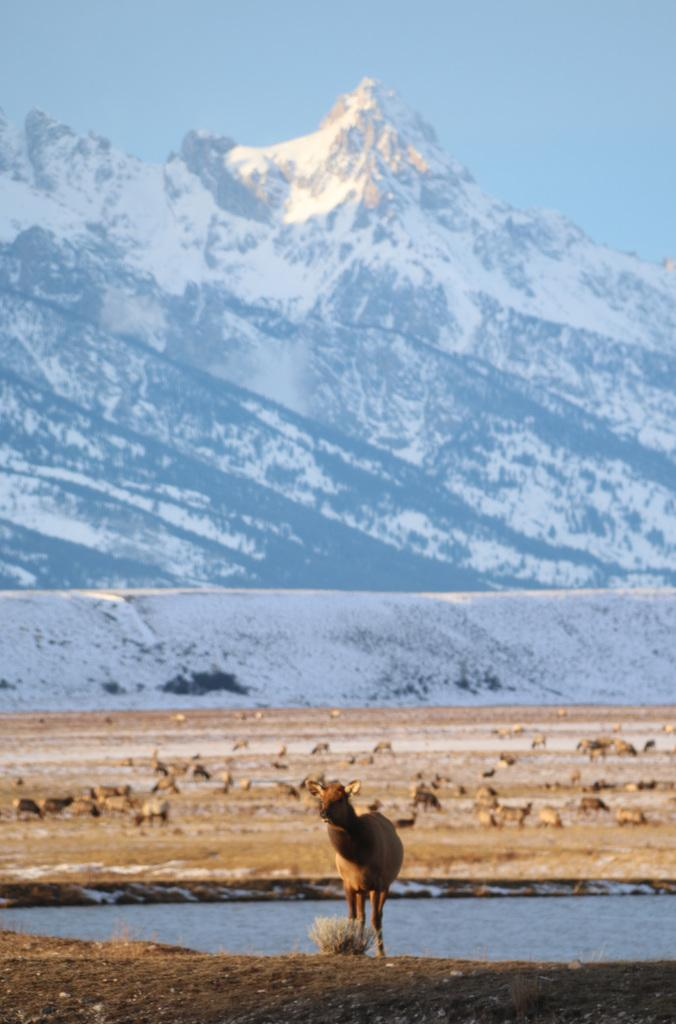What types of animals can be seen in the image? There are animals on the ground in the image. What natural element is visible in the image? There is water visible in the image. What can be seen in the distance in the image? There are mountains in the background of the image. How many girls are working on the farm in the image? There are no girls or farm present in the image. 